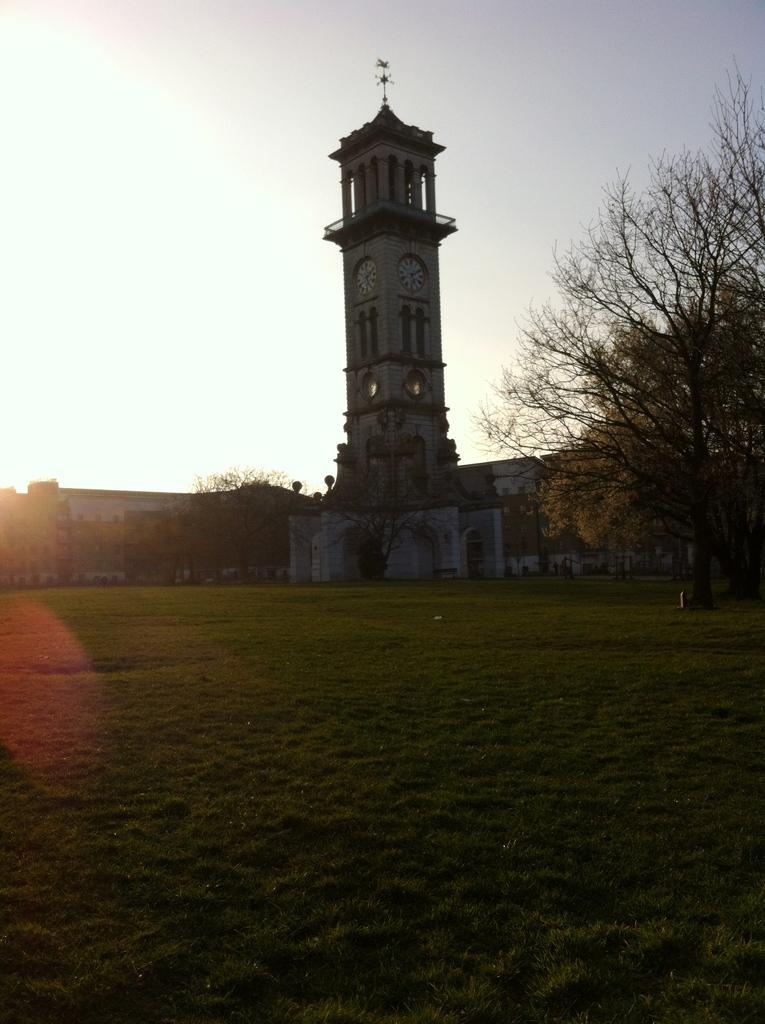Describe this image in one or two sentences. On the ground there is grass. In the background there are trees and buildings. There is a tower with arches, pillars and clocks. In the background there is sky. 